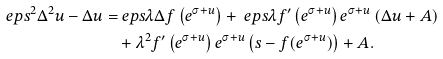<formula> <loc_0><loc_0><loc_500><loc_500>\ e p s ^ { 2 } \Delta ^ { 2 } u - \Delta u = & \ e p s \lambda \Delta f \left ( e ^ { \sigma + u } \right ) + \ e p s \lambda f ^ { \prime } \left ( e ^ { \sigma + u } \right ) e ^ { \sigma + u } \left ( \Delta u + A \right ) \\ & + \lambda ^ { 2 } f ^ { \prime } \left ( e ^ { \sigma + u } \right ) e ^ { \sigma + u } \left ( s - f ( e ^ { \sigma + u } ) \right ) + A .</formula> 